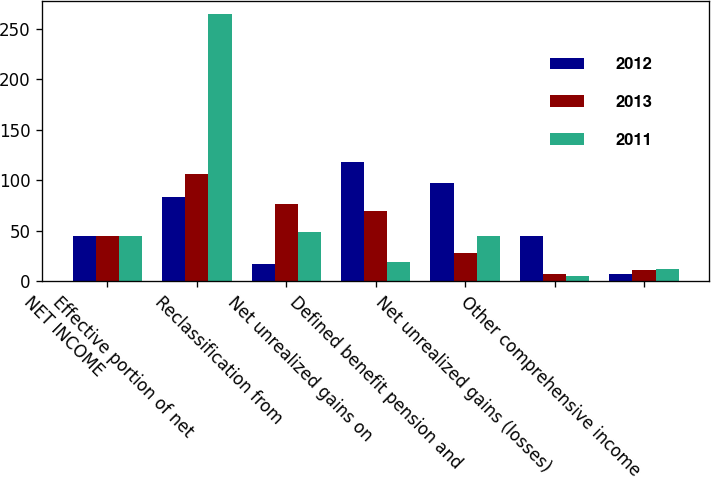<chart> <loc_0><loc_0><loc_500><loc_500><stacked_bar_chart><ecel><fcel>NET INCOME<fcel>Effective portion of net<fcel>Reclassification from<fcel>Net unrealized gains on<fcel>Defined benefit pension and<fcel>Net unrealized gains (losses)<fcel>Other comprehensive income<nl><fcel>2012<fcel>45<fcel>84<fcel>17<fcel>118<fcel>97<fcel>45<fcel>7<nl><fcel>2013<fcel>45<fcel>106<fcel>77<fcel>70<fcel>28<fcel>7<fcel>11<nl><fcel>2011<fcel>45<fcel>265<fcel>49<fcel>19<fcel>45<fcel>5<fcel>12<nl></chart> 